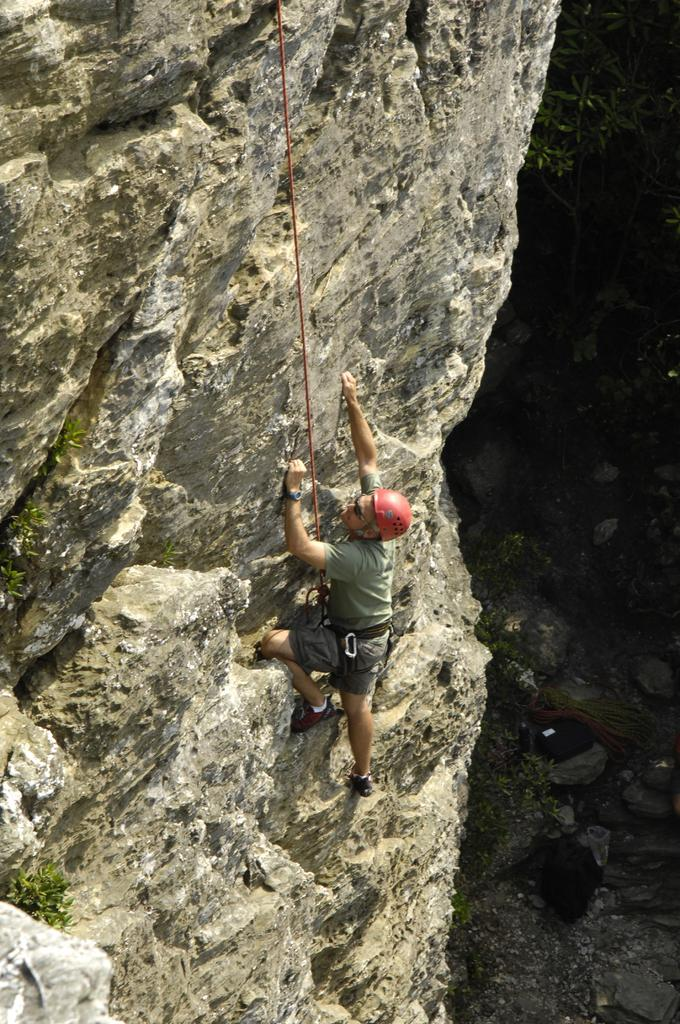Who is the person in the image? There is a man in the image. What is the man doing in the image? The man is climbing a hill. Is the man alone in the image? The facts provided do not mention any other people in the image. How is the man secured while climbing the hill? The man is tied with a rope. What type of icicle can be seen hanging from the man's hat in the image? There is no icicle present in the image, nor is there any mention of a hat. 